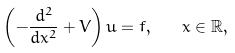<formula> <loc_0><loc_0><loc_500><loc_500>\left ( - \frac { d ^ { 2 } } { d x ^ { 2 } } + V \right ) u = f , \quad x \in \mathbb { R } ,</formula> 